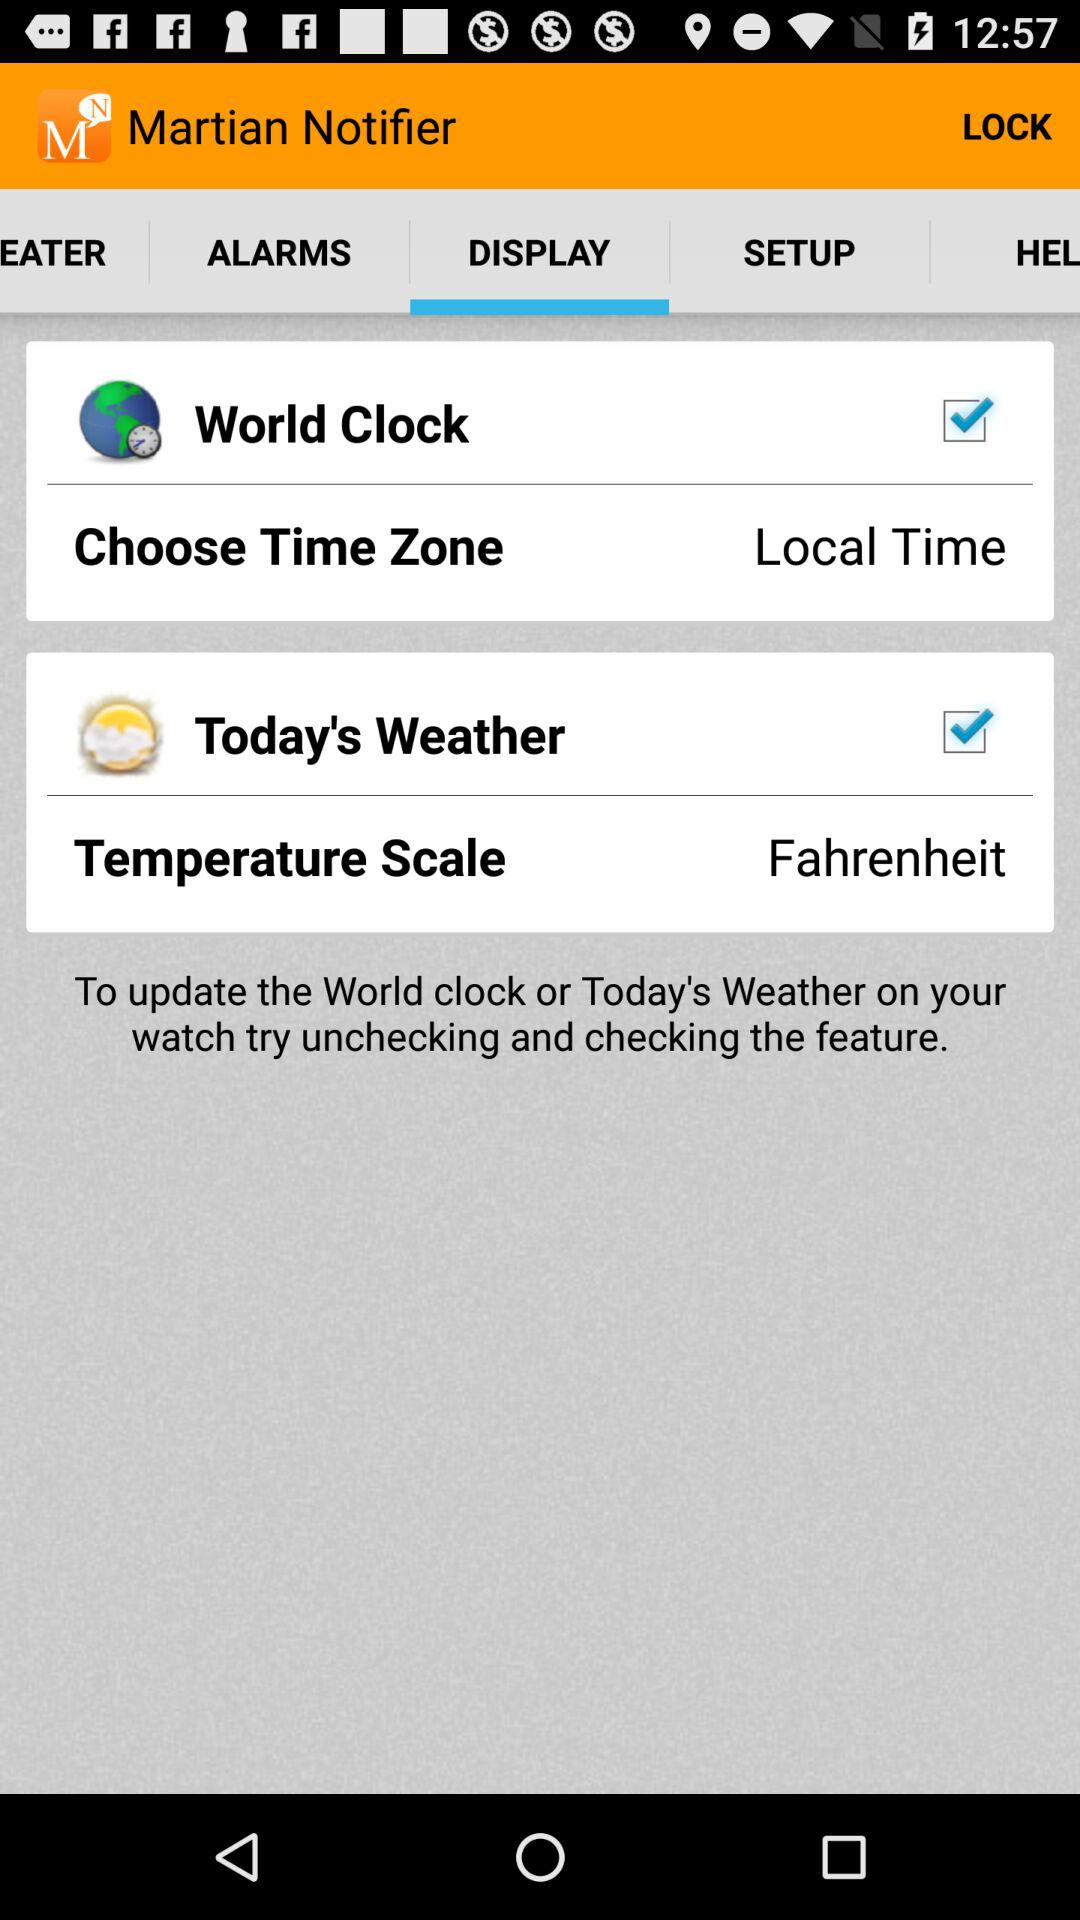What unit is used for the temperature scale? The unit is Fahrenheit. 